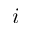<formula> <loc_0><loc_0><loc_500><loc_500>i</formula> 